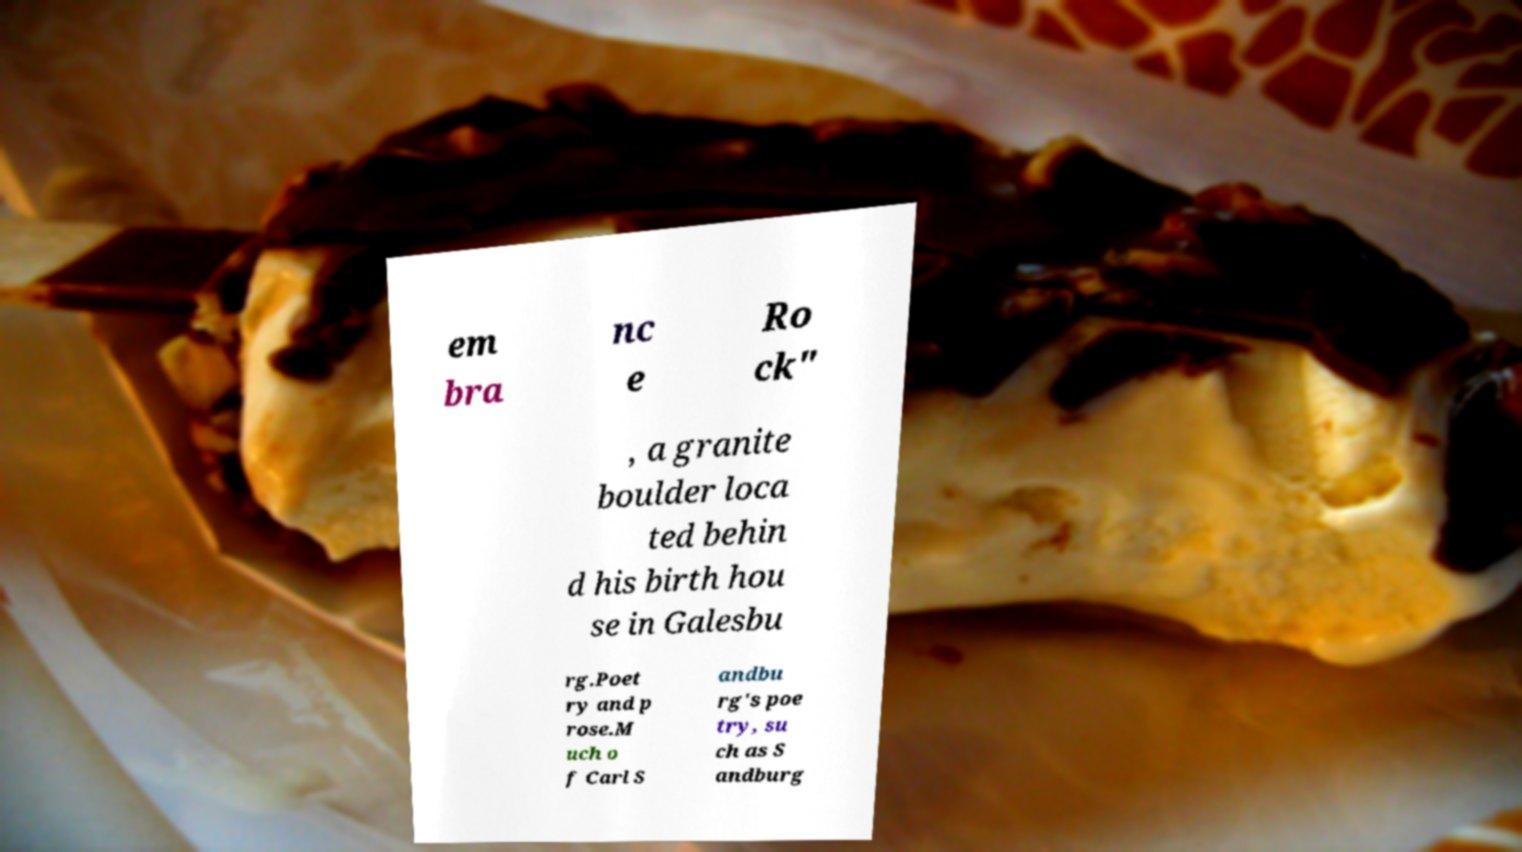Please read and relay the text visible in this image. What does it say? em bra nc e Ro ck" , a granite boulder loca ted behin d his birth hou se in Galesbu rg.Poet ry and p rose.M uch o f Carl S andbu rg's poe try, su ch as S andburg 